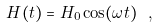Convert formula to latex. <formula><loc_0><loc_0><loc_500><loc_500>H ( t ) = H _ { 0 } \cos ( \omega t ) \ ,</formula> 